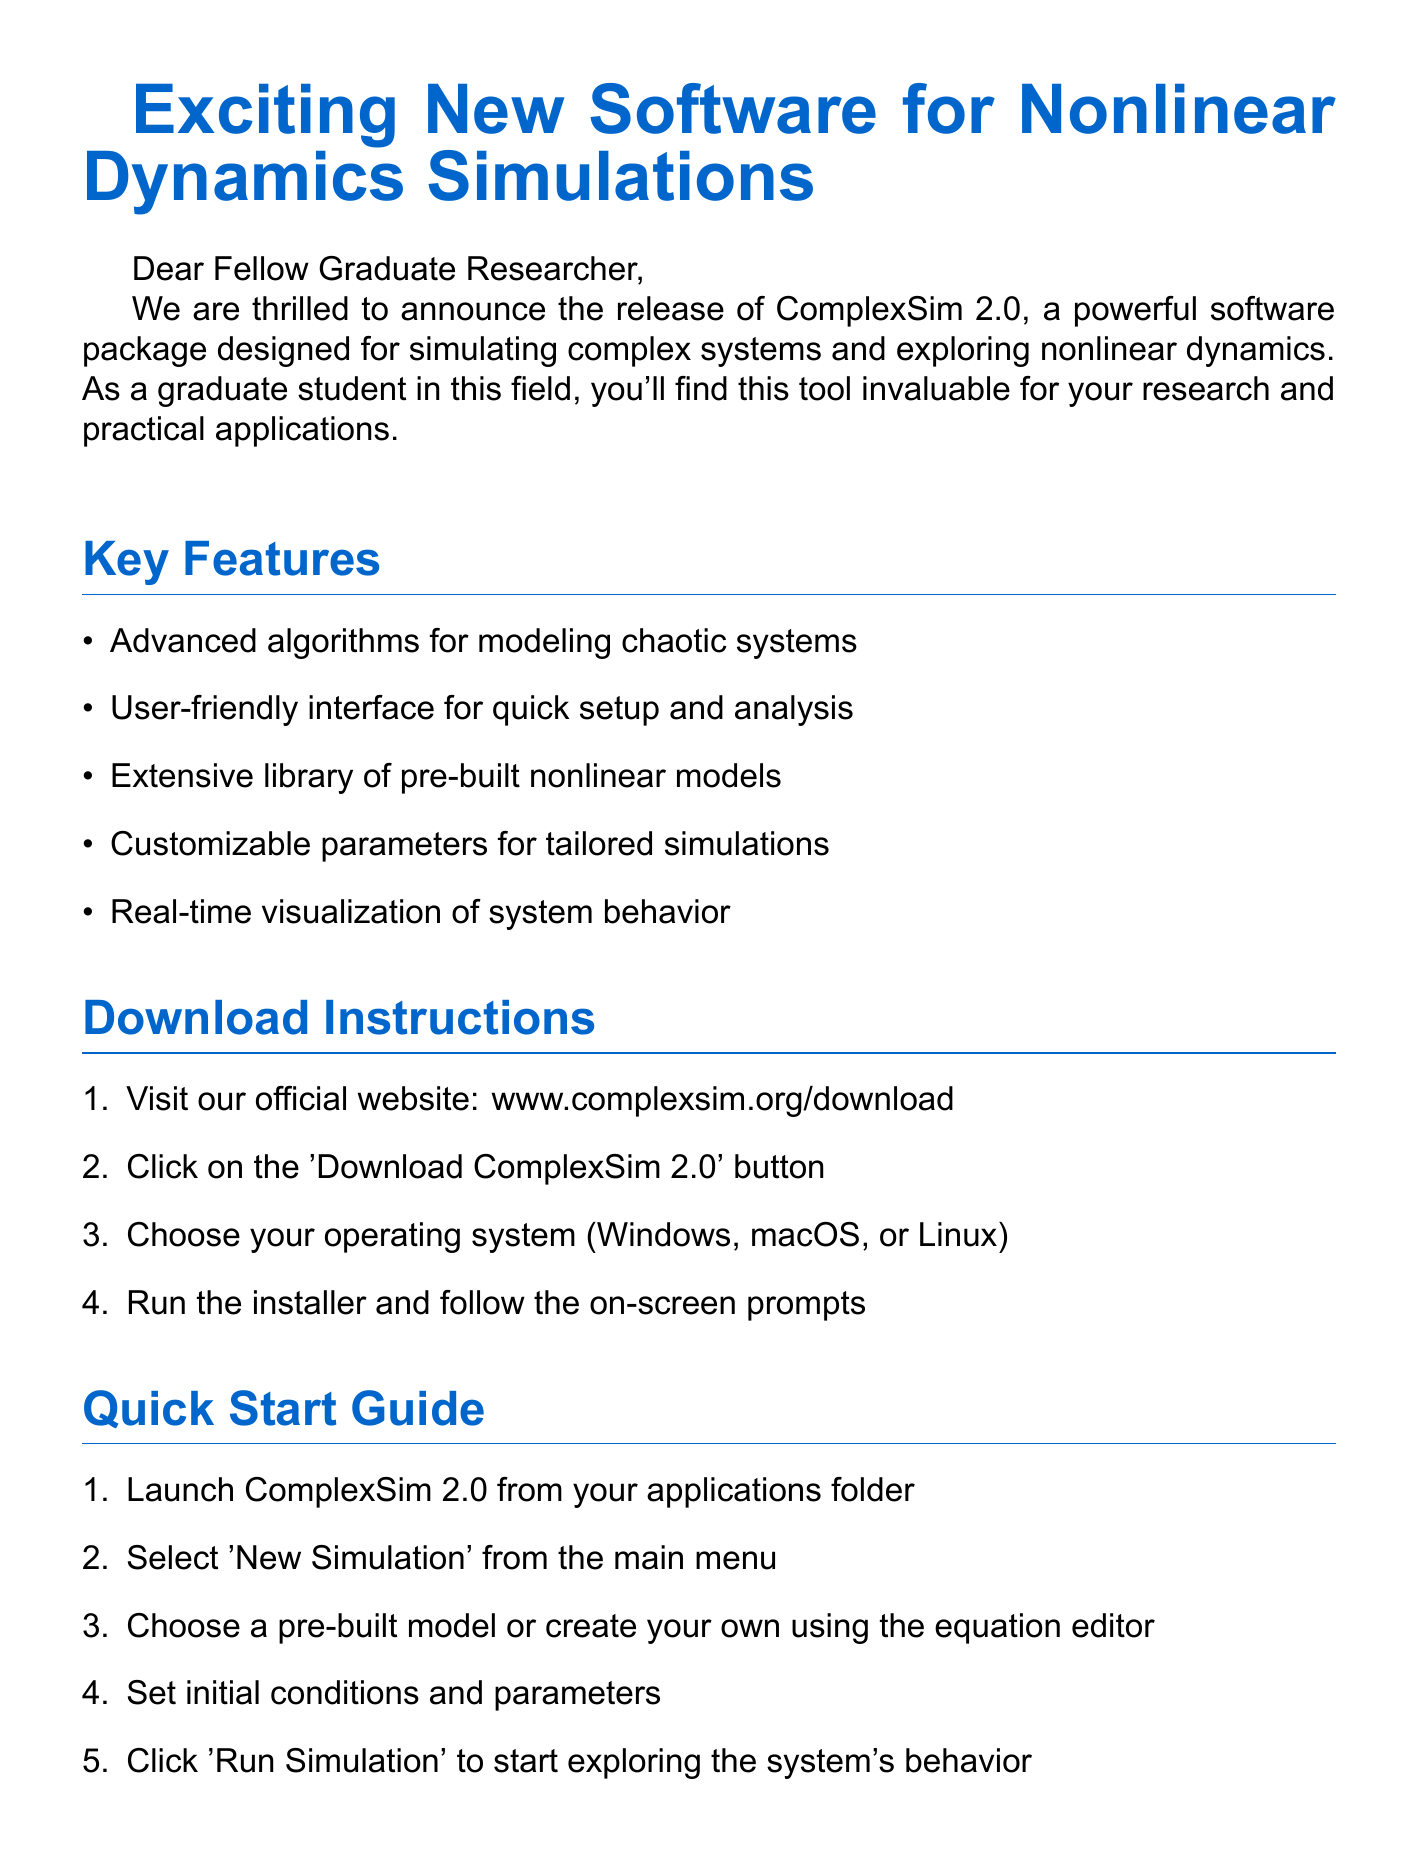What is the name of the software? The software's name is included in the subject and introduction of the document.
Answer: ComplexSim 2.0 How many key features are listed? The number of key features is found by counting the bullet points in the key features section.
Answer: Five What is the first step in download instructions? The first step is stated in the download instructions section of the document.
Answer: Visit our official website: www.complexsim.org/download Which operating systems are supported by ComplexSim 2.0? Supported operating systems are mentioned in the download instructions.
Answer: Windows, macOS, Linux What is the email address for support? The support email is given in the closing of the document.
Answer: support@complexsim.org What type of modeling can ComplexSim 2.0 help with? The practical applications section lists areas that the software can assist with.
Answer: Ecosystem modeling What is the last step in the quick start guide? The final step is outlined in the quick start guide section of the document.
Answer: Click 'Run Simulation' to start exploring the system's behavior What is the target audience for ComplexSim 2.0? The introduction specifies who will find the tool invaluable.
Answer: Graduate students How is the user interface described? The description of the user interface is mentioned in the key features section.
Answer: User-friendly 